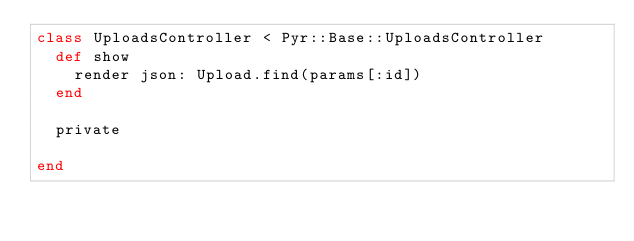Convert code to text. <code><loc_0><loc_0><loc_500><loc_500><_Ruby_>class UploadsController < Pyr::Base::UploadsController
  def show
    render json: Upload.find(params[:id])
  end

  private

end
</code> 